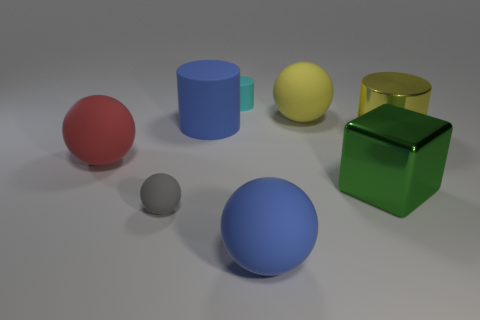Add 2 tiny things. How many objects exist? 10 Subtract all cubes. How many objects are left? 7 Add 7 green metallic blocks. How many green metallic blocks exist? 8 Subtract 1 red spheres. How many objects are left? 7 Subtract all small cyan cylinders. Subtract all green shiny things. How many objects are left? 6 Add 3 yellow matte spheres. How many yellow matte spheres are left? 4 